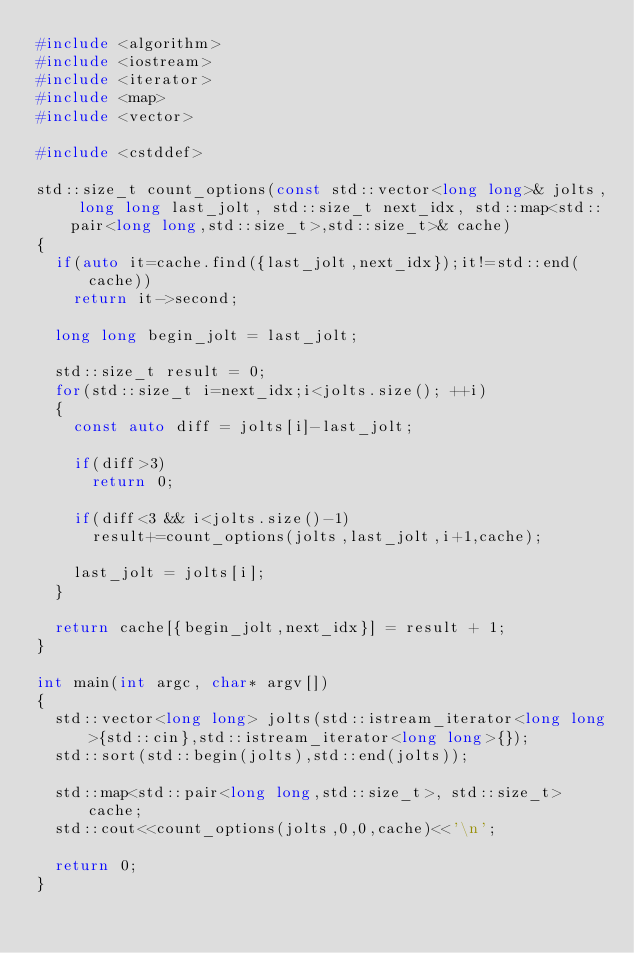<code> <loc_0><loc_0><loc_500><loc_500><_C++_>#include <algorithm>
#include <iostream>
#include <iterator>
#include <map>
#include <vector>

#include <cstddef>

std::size_t count_options(const std::vector<long long>& jolts, long long last_jolt, std::size_t next_idx, std::map<std::pair<long long,std::size_t>,std::size_t>& cache)
{
	if(auto it=cache.find({last_jolt,next_idx});it!=std::end(cache))
		return it->second;
		
	long long begin_jolt = last_jolt;
	
	std::size_t result = 0;
	for(std::size_t i=next_idx;i<jolts.size(); ++i)
	{
		const auto diff = jolts[i]-last_jolt;
		
		if(diff>3)
			return 0;
			
		if(diff<3 && i<jolts.size()-1)
			result+=count_options(jolts,last_jolt,i+1,cache);
		
		last_jolt = jolts[i];
	}
	
	return cache[{begin_jolt,next_idx}] = result + 1;
}

int main(int argc, char* argv[])
{
	std::vector<long long> jolts(std::istream_iterator<long long>{std::cin},std::istream_iterator<long long>{});
	std::sort(std::begin(jolts),std::end(jolts));
	
	std::map<std::pair<long long,std::size_t>, std::size_t> cache;
	std::cout<<count_options(jolts,0,0,cache)<<'\n';

	return 0;
}
</code> 